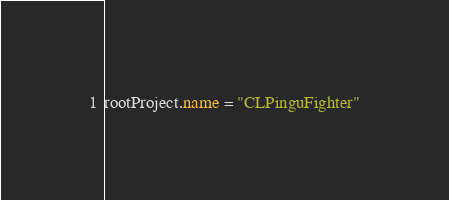<code> <loc_0><loc_0><loc_500><loc_500><_Kotlin_>rootProject.name = "CLPinguFighter"
</code> 